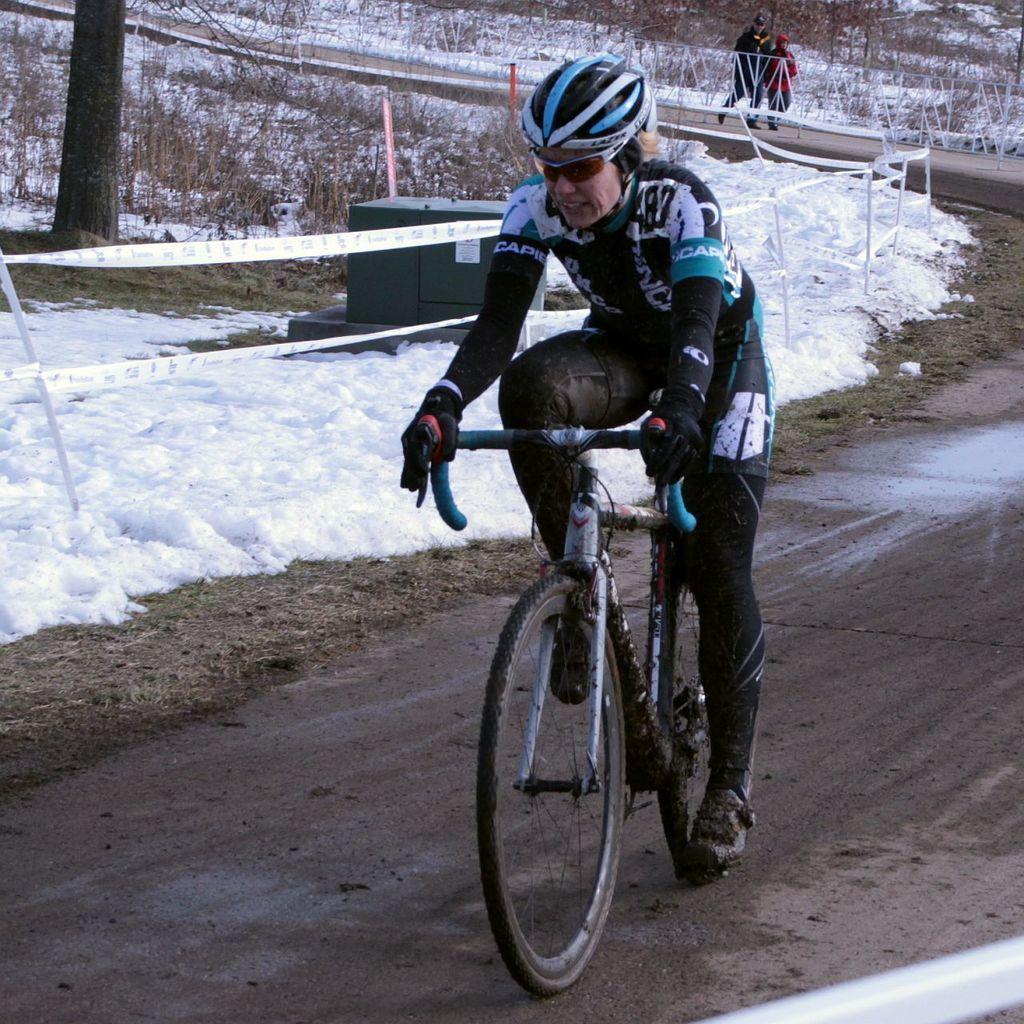Could you give a brief overview of what you see in this image? In this picture we can see one person is riding a bicycle on the road, beside we can see snow and few trees. 